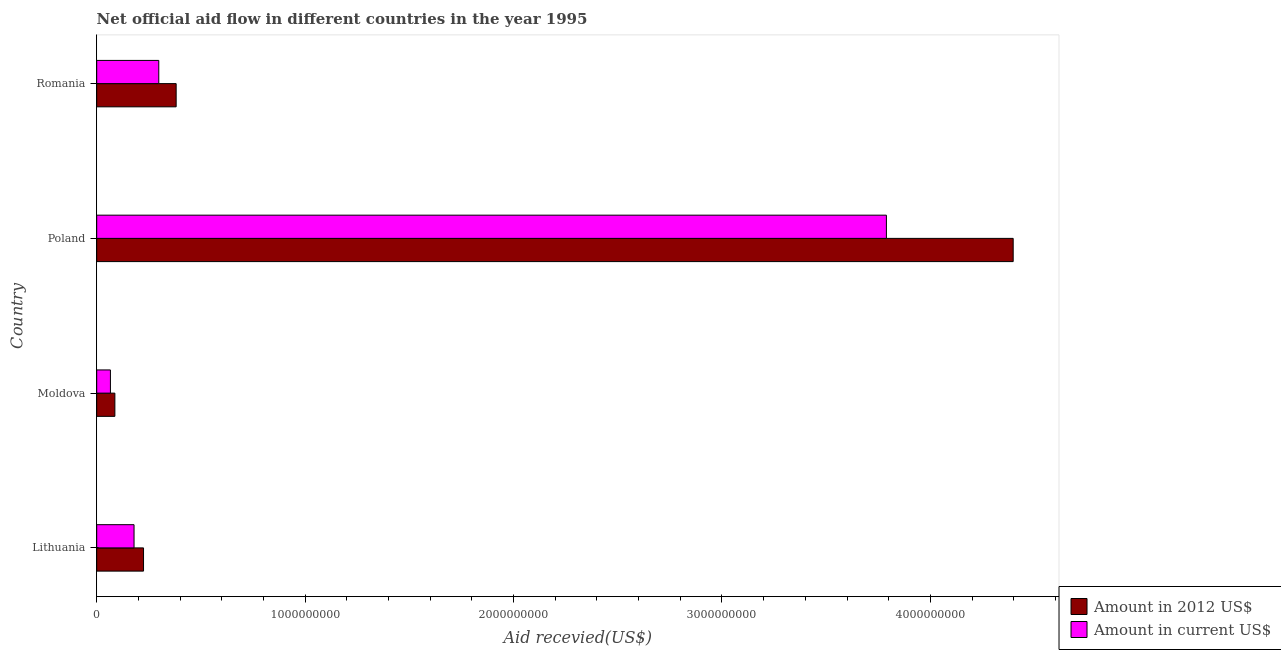How many different coloured bars are there?
Ensure brevity in your answer.  2. How many groups of bars are there?
Your response must be concise. 4. How many bars are there on the 2nd tick from the top?
Give a very brief answer. 2. What is the label of the 4th group of bars from the top?
Your answer should be compact. Lithuania. In how many cases, is the number of bars for a given country not equal to the number of legend labels?
Offer a very short reply. 0. What is the amount of aid received(expressed in us$) in Romania?
Provide a short and direct response. 2.98e+08. Across all countries, what is the maximum amount of aid received(expressed in 2012 us$)?
Offer a very short reply. 4.40e+09. Across all countries, what is the minimum amount of aid received(expressed in 2012 us$)?
Make the answer very short. 8.72e+07. In which country was the amount of aid received(expressed in 2012 us$) minimum?
Provide a succinct answer. Moldova. What is the total amount of aid received(expressed in us$) in the graph?
Your response must be concise. 4.33e+09. What is the difference between the amount of aid received(expressed in 2012 us$) in Moldova and that in Romania?
Give a very brief answer. -2.94e+08. What is the difference between the amount of aid received(expressed in us$) in Romania and the amount of aid received(expressed in 2012 us$) in Poland?
Your answer should be very brief. -4.10e+09. What is the average amount of aid received(expressed in 2012 us$) per country?
Offer a terse response. 1.27e+09. What is the difference between the amount of aid received(expressed in us$) and amount of aid received(expressed in 2012 us$) in Romania?
Make the answer very short. -8.33e+07. What is the ratio of the amount of aid received(expressed in 2012 us$) in Lithuania to that in Moldova?
Keep it short and to the point. 2.58. What is the difference between the highest and the second highest amount of aid received(expressed in us$)?
Offer a terse response. 3.49e+09. What is the difference between the highest and the lowest amount of aid received(expressed in 2012 us$)?
Give a very brief answer. 4.31e+09. In how many countries, is the amount of aid received(expressed in us$) greater than the average amount of aid received(expressed in us$) taken over all countries?
Ensure brevity in your answer.  1. What does the 1st bar from the top in Moldova represents?
Offer a terse response. Amount in current US$. What does the 1st bar from the bottom in Poland represents?
Give a very brief answer. Amount in 2012 US$. Are all the bars in the graph horizontal?
Offer a very short reply. Yes. Does the graph contain grids?
Keep it short and to the point. No. How many legend labels are there?
Keep it short and to the point. 2. What is the title of the graph?
Give a very brief answer. Net official aid flow in different countries in the year 1995. What is the label or title of the X-axis?
Keep it short and to the point. Aid recevied(US$). What is the Aid recevied(US$) in Amount in 2012 US$ in Lithuania?
Make the answer very short. 2.25e+08. What is the Aid recevied(US$) in Amount in current US$ in Lithuania?
Offer a very short reply. 1.79e+08. What is the Aid recevied(US$) of Amount in 2012 US$ in Moldova?
Provide a succinct answer. 8.72e+07. What is the Aid recevied(US$) of Amount in current US$ in Moldova?
Provide a succinct answer. 6.58e+07. What is the Aid recevied(US$) in Amount in 2012 US$ in Poland?
Your answer should be very brief. 4.40e+09. What is the Aid recevied(US$) in Amount in current US$ in Poland?
Offer a terse response. 3.79e+09. What is the Aid recevied(US$) of Amount in 2012 US$ in Romania?
Provide a short and direct response. 3.81e+08. What is the Aid recevied(US$) in Amount in current US$ in Romania?
Your response must be concise. 2.98e+08. Across all countries, what is the maximum Aid recevied(US$) in Amount in 2012 US$?
Keep it short and to the point. 4.40e+09. Across all countries, what is the maximum Aid recevied(US$) in Amount in current US$?
Offer a very short reply. 3.79e+09. Across all countries, what is the minimum Aid recevied(US$) in Amount in 2012 US$?
Your answer should be very brief. 8.72e+07. Across all countries, what is the minimum Aid recevied(US$) in Amount in current US$?
Keep it short and to the point. 6.58e+07. What is the total Aid recevied(US$) of Amount in 2012 US$ in the graph?
Your answer should be compact. 5.09e+09. What is the total Aid recevied(US$) of Amount in current US$ in the graph?
Make the answer very short. 4.33e+09. What is the difference between the Aid recevied(US$) in Amount in 2012 US$ in Lithuania and that in Moldova?
Your answer should be compact. 1.37e+08. What is the difference between the Aid recevied(US$) of Amount in current US$ in Lithuania and that in Moldova?
Make the answer very short. 1.13e+08. What is the difference between the Aid recevied(US$) in Amount in 2012 US$ in Lithuania and that in Poland?
Your response must be concise. -4.17e+09. What is the difference between the Aid recevied(US$) in Amount in current US$ in Lithuania and that in Poland?
Keep it short and to the point. -3.61e+09. What is the difference between the Aid recevied(US$) in Amount in 2012 US$ in Lithuania and that in Romania?
Provide a short and direct response. -1.57e+08. What is the difference between the Aid recevied(US$) in Amount in current US$ in Lithuania and that in Romania?
Offer a terse response. -1.19e+08. What is the difference between the Aid recevied(US$) of Amount in 2012 US$ in Moldova and that in Poland?
Provide a short and direct response. -4.31e+09. What is the difference between the Aid recevied(US$) of Amount in current US$ in Moldova and that in Poland?
Your answer should be compact. -3.72e+09. What is the difference between the Aid recevied(US$) of Amount in 2012 US$ in Moldova and that in Romania?
Give a very brief answer. -2.94e+08. What is the difference between the Aid recevied(US$) of Amount in current US$ in Moldova and that in Romania?
Keep it short and to the point. -2.32e+08. What is the difference between the Aid recevied(US$) in Amount in 2012 US$ in Poland and that in Romania?
Provide a succinct answer. 4.02e+09. What is the difference between the Aid recevied(US$) in Amount in current US$ in Poland and that in Romania?
Provide a succinct answer. 3.49e+09. What is the difference between the Aid recevied(US$) of Amount in 2012 US$ in Lithuania and the Aid recevied(US$) of Amount in current US$ in Moldova?
Offer a terse response. 1.59e+08. What is the difference between the Aid recevied(US$) in Amount in 2012 US$ in Lithuania and the Aid recevied(US$) in Amount in current US$ in Poland?
Make the answer very short. -3.56e+09. What is the difference between the Aid recevied(US$) in Amount in 2012 US$ in Lithuania and the Aid recevied(US$) in Amount in current US$ in Romania?
Keep it short and to the point. -7.32e+07. What is the difference between the Aid recevied(US$) of Amount in 2012 US$ in Moldova and the Aid recevied(US$) of Amount in current US$ in Poland?
Your answer should be very brief. -3.70e+09. What is the difference between the Aid recevied(US$) of Amount in 2012 US$ in Moldova and the Aid recevied(US$) of Amount in current US$ in Romania?
Provide a short and direct response. -2.11e+08. What is the difference between the Aid recevied(US$) in Amount in 2012 US$ in Poland and the Aid recevied(US$) in Amount in current US$ in Romania?
Offer a very short reply. 4.10e+09. What is the average Aid recevied(US$) in Amount in 2012 US$ per country?
Offer a very short reply. 1.27e+09. What is the average Aid recevied(US$) in Amount in current US$ per country?
Provide a short and direct response. 1.08e+09. What is the difference between the Aid recevied(US$) in Amount in 2012 US$ and Aid recevied(US$) in Amount in current US$ in Lithuania?
Your answer should be very brief. 4.55e+07. What is the difference between the Aid recevied(US$) of Amount in 2012 US$ and Aid recevied(US$) of Amount in current US$ in Moldova?
Make the answer very short. 2.13e+07. What is the difference between the Aid recevied(US$) of Amount in 2012 US$ and Aid recevied(US$) of Amount in current US$ in Poland?
Offer a very short reply. 6.08e+08. What is the difference between the Aid recevied(US$) in Amount in 2012 US$ and Aid recevied(US$) in Amount in current US$ in Romania?
Offer a terse response. 8.33e+07. What is the ratio of the Aid recevied(US$) of Amount in 2012 US$ in Lithuania to that in Moldova?
Ensure brevity in your answer.  2.58. What is the ratio of the Aid recevied(US$) of Amount in current US$ in Lithuania to that in Moldova?
Offer a terse response. 2.72. What is the ratio of the Aid recevied(US$) in Amount in 2012 US$ in Lithuania to that in Poland?
Make the answer very short. 0.05. What is the ratio of the Aid recevied(US$) in Amount in current US$ in Lithuania to that in Poland?
Make the answer very short. 0.05. What is the ratio of the Aid recevied(US$) of Amount in 2012 US$ in Lithuania to that in Romania?
Your response must be concise. 0.59. What is the ratio of the Aid recevied(US$) in Amount in current US$ in Lithuania to that in Romania?
Keep it short and to the point. 0.6. What is the ratio of the Aid recevied(US$) in Amount in 2012 US$ in Moldova to that in Poland?
Your answer should be compact. 0.02. What is the ratio of the Aid recevied(US$) in Amount in current US$ in Moldova to that in Poland?
Make the answer very short. 0.02. What is the ratio of the Aid recevied(US$) in Amount in 2012 US$ in Moldova to that in Romania?
Offer a very short reply. 0.23. What is the ratio of the Aid recevied(US$) in Amount in current US$ in Moldova to that in Romania?
Give a very brief answer. 0.22. What is the ratio of the Aid recevied(US$) in Amount in 2012 US$ in Poland to that in Romania?
Your answer should be compact. 11.54. What is the ratio of the Aid recevied(US$) in Amount in current US$ in Poland to that in Romania?
Your answer should be compact. 12.72. What is the difference between the highest and the second highest Aid recevied(US$) of Amount in 2012 US$?
Offer a very short reply. 4.02e+09. What is the difference between the highest and the second highest Aid recevied(US$) of Amount in current US$?
Provide a short and direct response. 3.49e+09. What is the difference between the highest and the lowest Aid recevied(US$) of Amount in 2012 US$?
Give a very brief answer. 4.31e+09. What is the difference between the highest and the lowest Aid recevied(US$) of Amount in current US$?
Make the answer very short. 3.72e+09. 